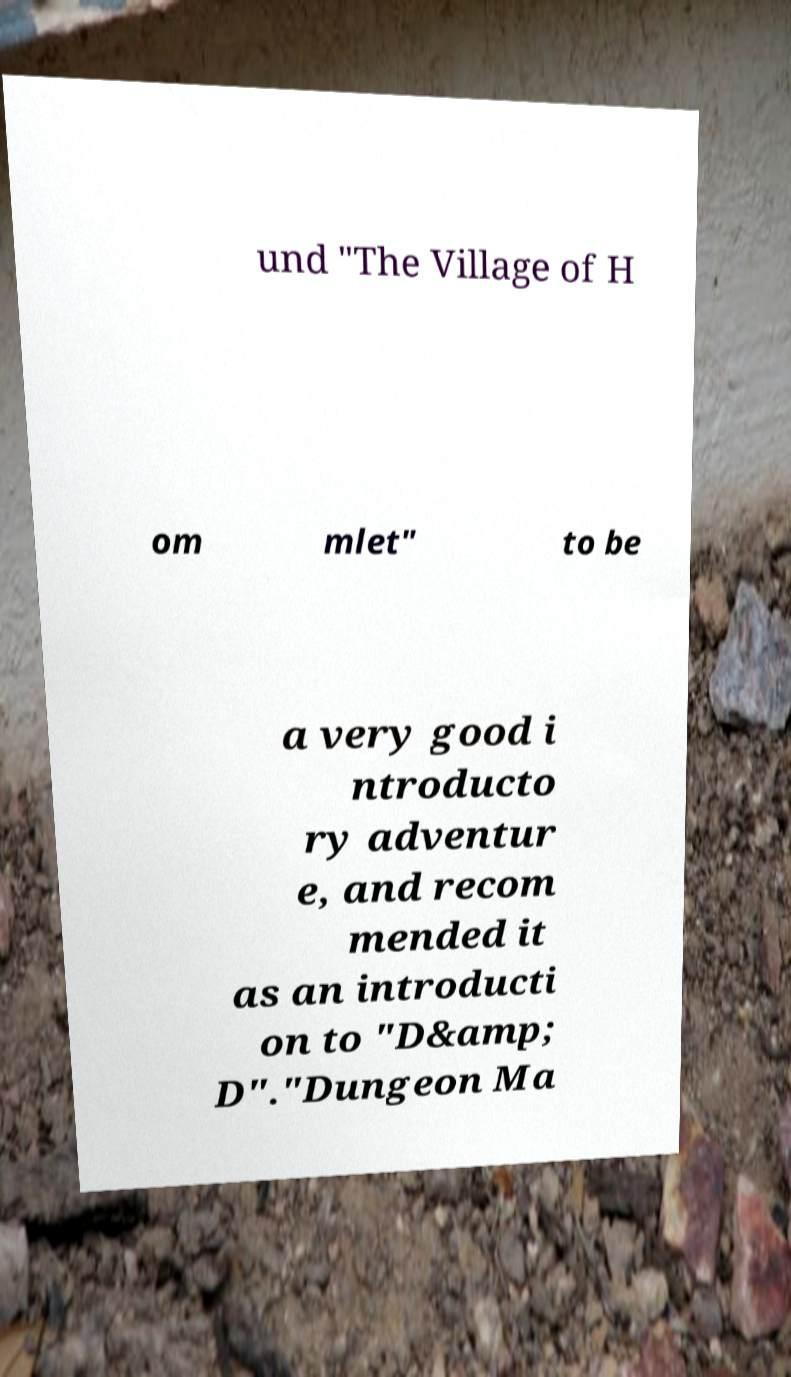I need the written content from this picture converted into text. Can you do that? und "The Village of H om mlet" to be a very good i ntroducto ry adventur e, and recom mended it as an introducti on to "D&amp; D"."Dungeon Ma 